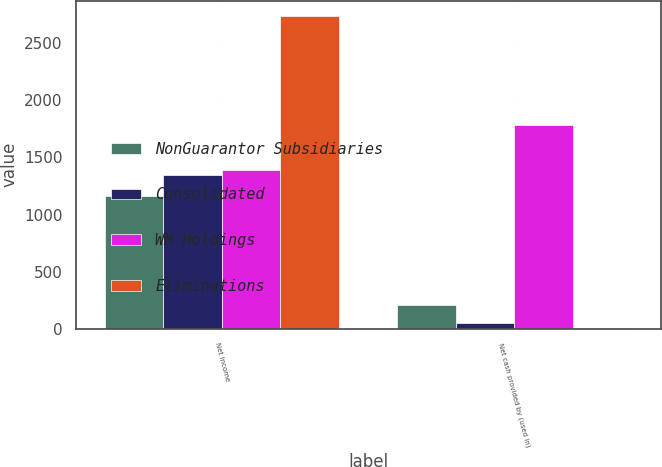<chart> <loc_0><loc_0><loc_500><loc_500><stacked_bar_chart><ecel><fcel>Net income<fcel>Net cash provided by (used in)<nl><fcel>NonGuarantor Subsidiaries<fcel>1163<fcel>206<nl><fcel>Consolidated<fcel>1347<fcel>49<nl><fcel>WM Holdings<fcel>1389<fcel>1782<nl><fcel>Eliminations<fcel>2736<fcel>7<nl></chart> 